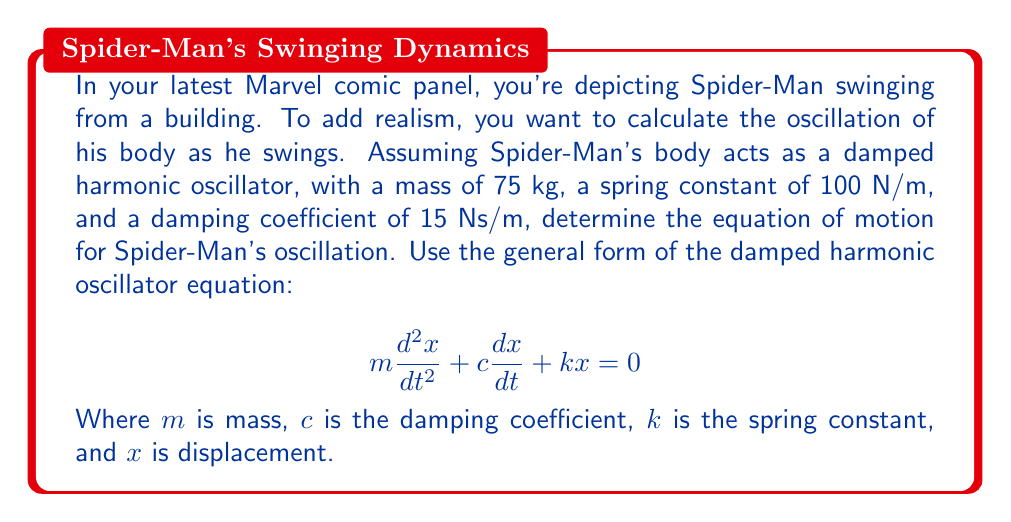Give your solution to this math problem. To solve this problem, we'll follow these steps:

1) First, let's identify the given values:
   $m = 75$ kg
   $k = 100$ N/m
   $c = 15$ Ns/m

2) Now, we'll substitute these values into the general equation:

   $$75\frac{d^2x}{dt^2} + 15\frac{dx}{dt} + 100x = 0$$

3) To simplify, we'll divide everything by 75:

   $$\frac{d^2x}{dt^2} + \frac{15}{75}\frac{dx}{dt} + \frac{100}{75}x = 0$$

4) Simplifying further:

   $$\frac{d^2x}{dt^2} + 0.2\frac{dx}{dt} + \frac{4}{3}x = 0$$

This is the final equation of motion for Spider-Man's oscillation as a damped harmonic oscillator.
Answer: $$\frac{d^2x}{dt^2} + 0.2\frac{dx}{dt} + \frac{4}{3}x = 0$$ 